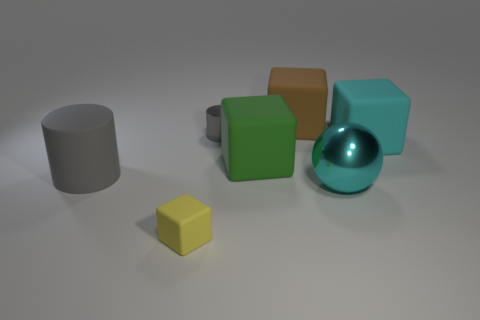The cyan sphere that is right of the gray cylinder that is on the right side of the gray object in front of the small cylinder is made of what material? The cyan sphere, placed to the right of the gray cylinder, exudes a metallic sheen indicating that it is likely made of a polished metal, giving it a reflective surface and smooth texture. 